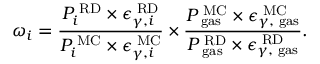<formula> <loc_0><loc_0><loc_500><loc_500>\omega _ { i } = \frac { { P _ { i } ^ { R D } \times \epsilon _ { \gamma , i } ^ { R D } } } { { P _ { i } ^ { M C } \times \epsilon _ { \gamma , i } ^ { M C } } } \times \frac { { P _ { g a s } ^ { M C } \times \epsilon _ { \gamma , g a s } ^ { M C } } } { { P _ { g a s } ^ { R D } \times \epsilon _ { \gamma , g a s } ^ { R D } } } .</formula> 